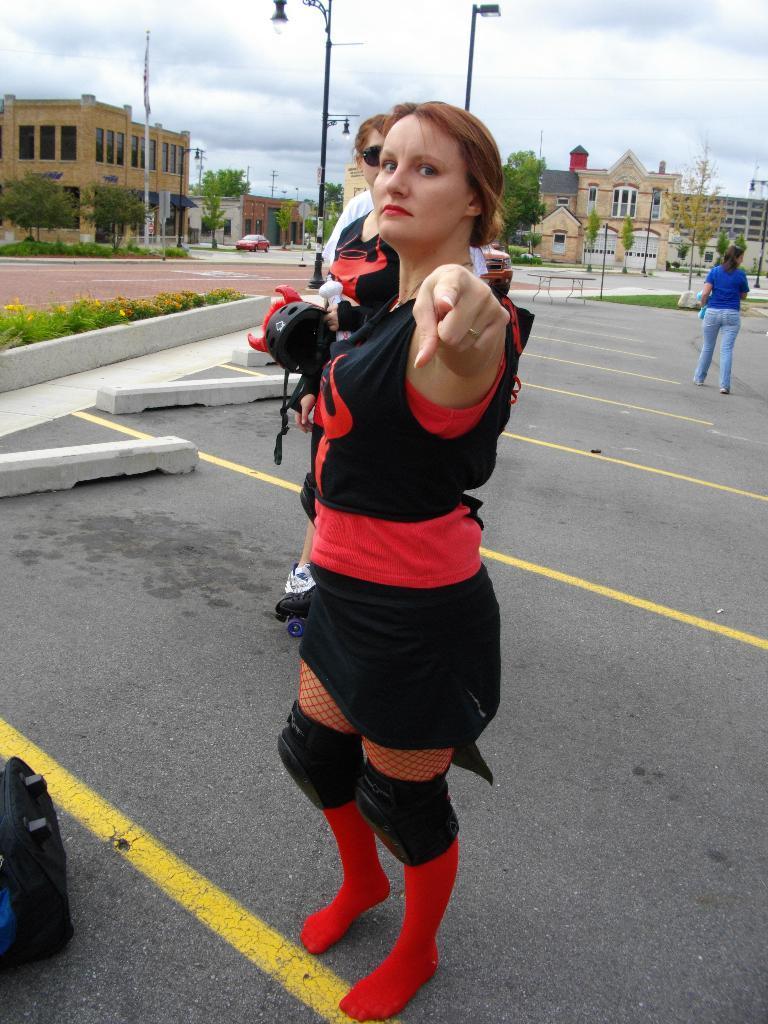Could you give a brief overview of what you see in this image? This image is taken outdoors. At the bottom of the image there is a road. At the top of the image there is the sky with clouds. In the background there are a few buildings with walls, windows, doors and roofs. There are a few poles with street lights. There are a few trees and plants. A car is moving on the road. In the middle of the image of a woman is standing on the road and a few people are standing. On the right side of the image a woman is walking on the road. On the left side of the image there are a few plants and there is a bag on the road. 